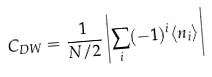Convert formula to latex. <formula><loc_0><loc_0><loc_500><loc_500>C _ { D W } = \frac { 1 } { N / 2 } \left | \sum _ { i } ( - 1 ) ^ { i } \langle n _ { i } \rangle \right |</formula> 